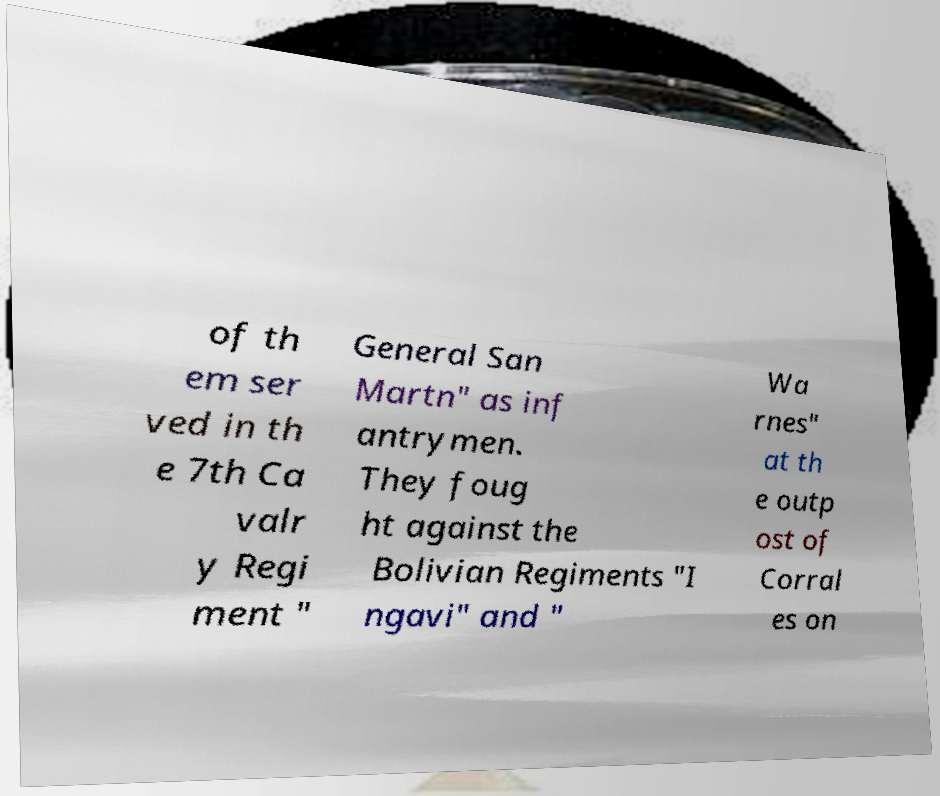For documentation purposes, I need the text within this image transcribed. Could you provide that? of th em ser ved in th e 7th Ca valr y Regi ment " General San Martn" as inf antrymen. They foug ht against the Bolivian Regiments "I ngavi" and " Wa rnes" at th e outp ost of Corral es on 